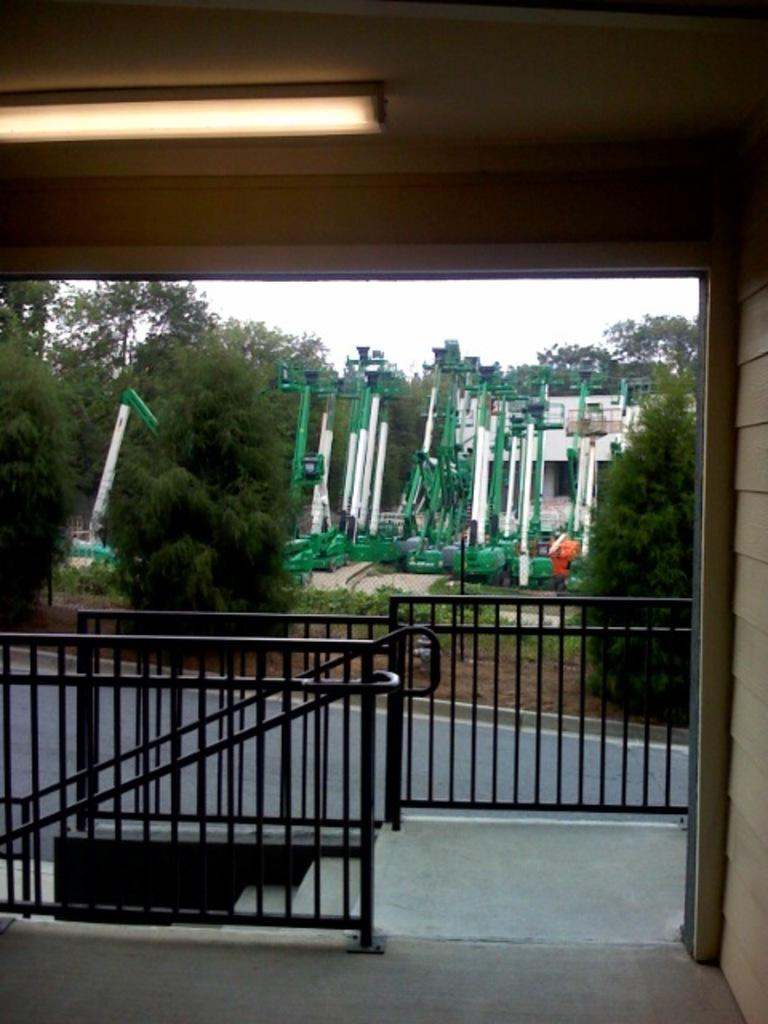Where was the image taken? The image was clicked outside. What is the main subject in the middle of the image? There is a building and trees in the middle of the image. What is visible at the top of the image? The sky is visible at the top of the image. What architectural feature can be seen at the bottom of the image? There are stairs at the bottom of the image. What type of lace can be seen on the scarecrow in the image? There is no scarecrow present in the image, so there is no lace to be seen. What song is being sung by the trees in the image? Trees do not sing songs, so there is no song being sung in the image. 